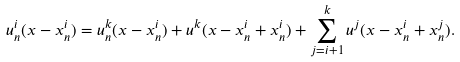<formula> <loc_0><loc_0><loc_500><loc_500>u ^ { i } _ { n } ( x - x ^ { i } _ { n } ) = u ^ { k } _ { n } ( x - x ^ { i } _ { n } ) + u ^ { k } ( x - x ^ { i } _ { n } + x ^ { i } _ { n } ) + \sum _ { j = i + 1 } ^ { k } u ^ { j } ( x - x ^ { i } _ { n } + x ^ { j } _ { n } ) .</formula> 